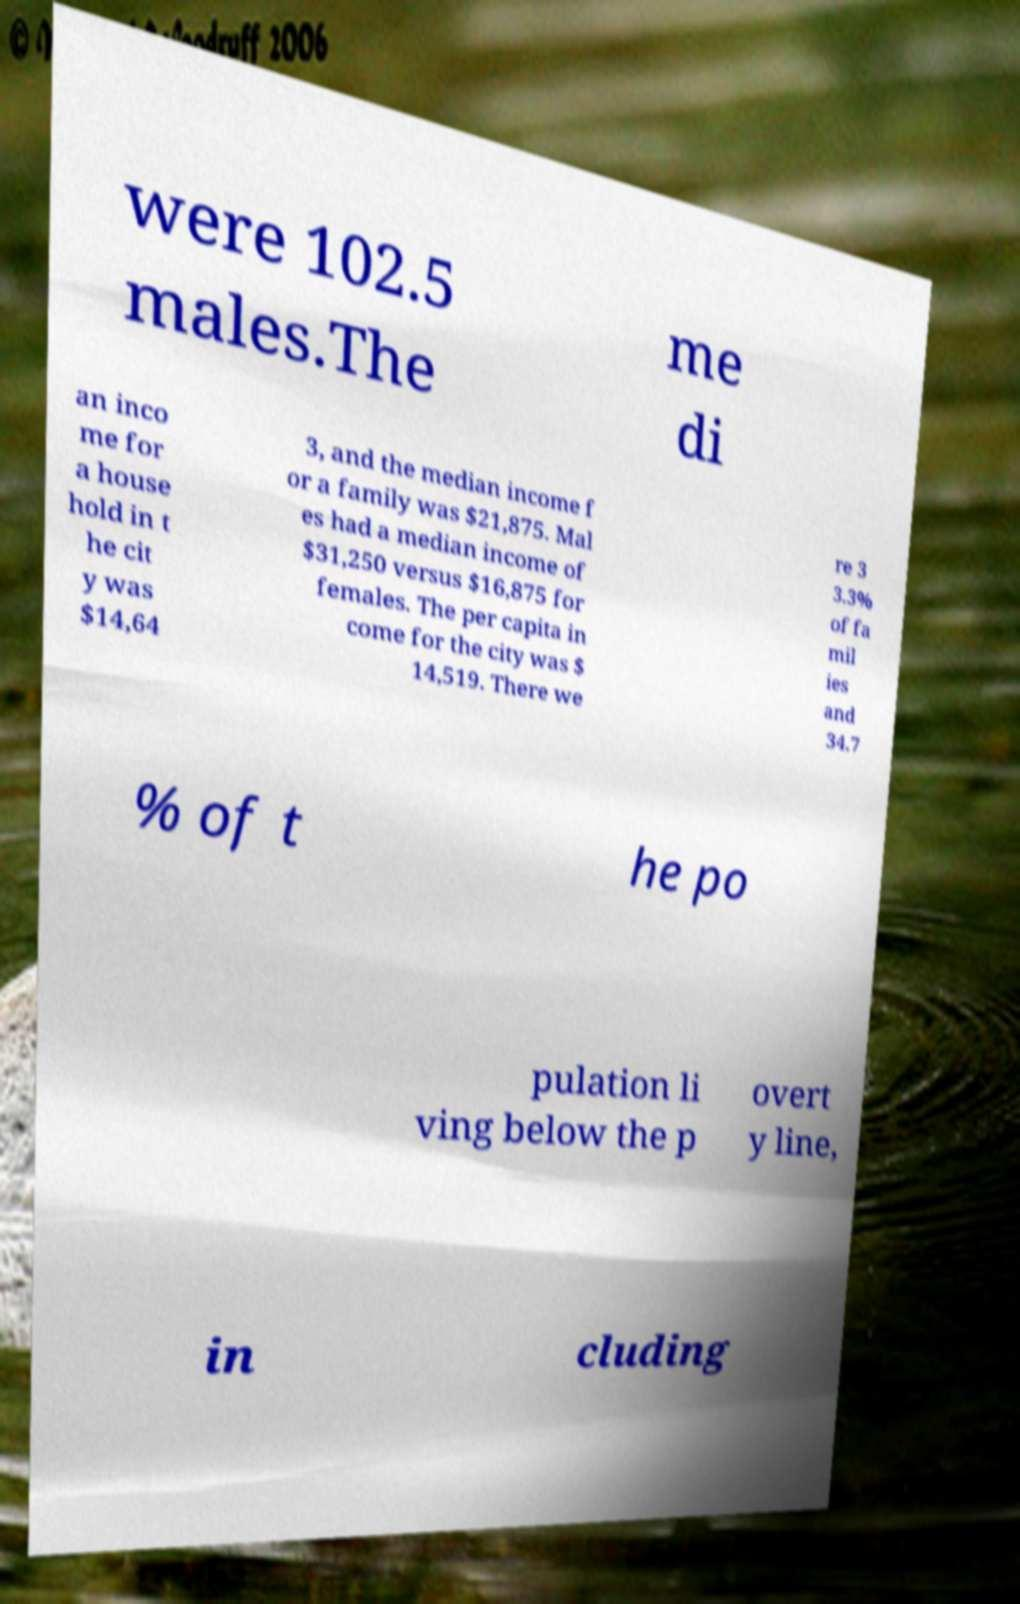Please identify and transcribe the text found in this image. were 102.5 males.The me di an inco me for a house hold in t he cit y was $14,64 3, and the median income f or a family was $21,875. Mal es had a median income of $31,250 versus $16,875 for females. The per capita in come for the city was $ 14,519. There we re 3 3.3% of fa mil ies and 34.7 % of t he po pulation li ving below the p overt y line, in cluding 